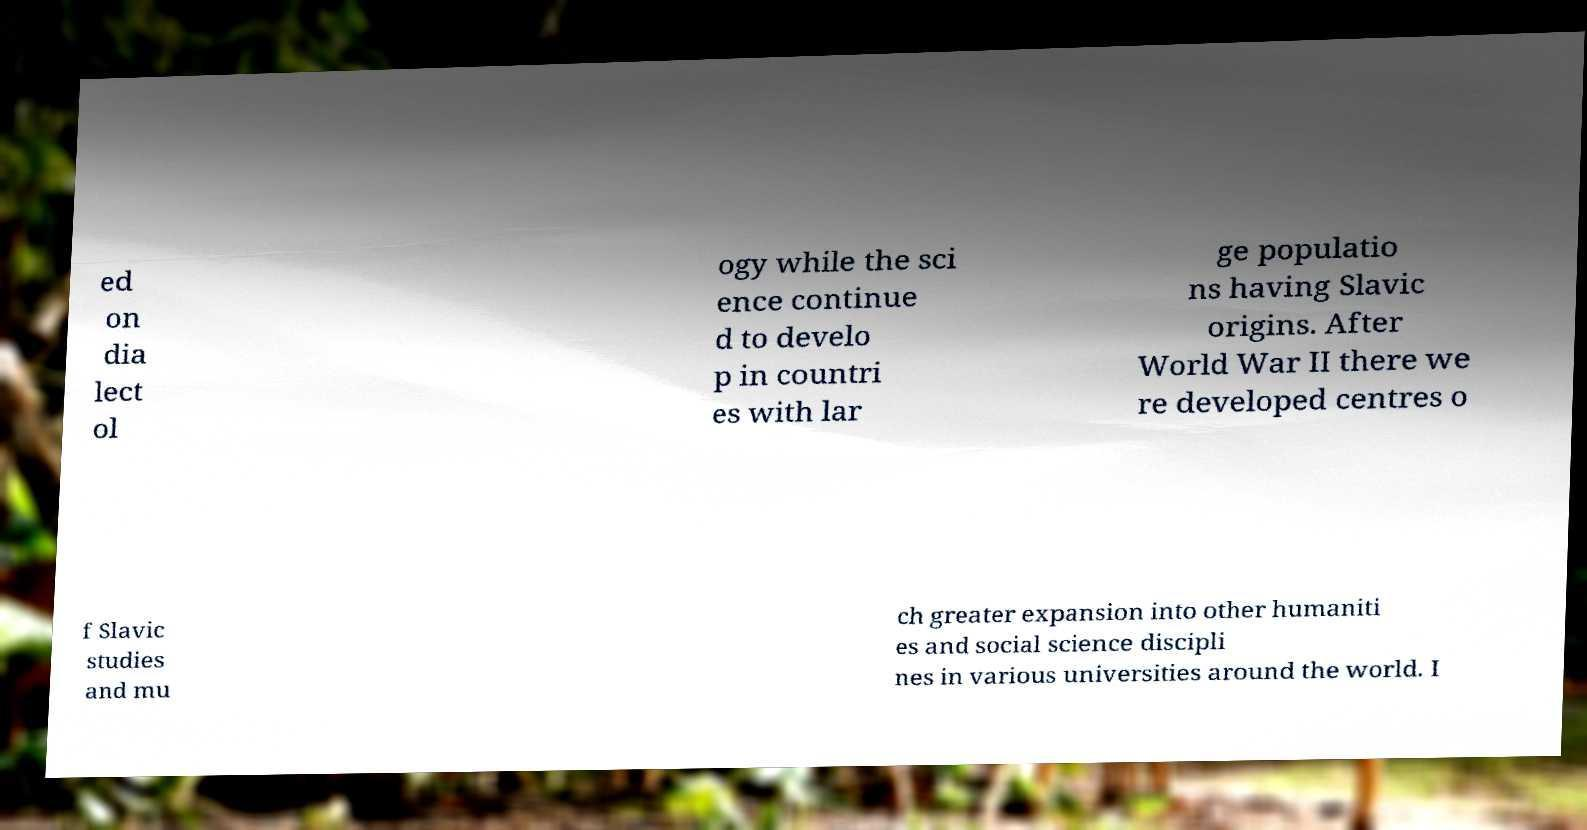Please identify and transcribe the text found in this image. ed on dia lect ol ogy while the sci ence continue d to develo p in countri es with lar ge populatio ns having Slavic origins. After World War II there we re developed centres o f Slavic studies and mu ch greater expansion into other humaniti es and social science discipli nes in various universities around the world. I 